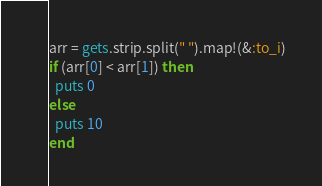Convert code to text. <code><loc_0><loc_0><loc_500><loc_500><_Ruby_>arr = gets.strip.split(" ").map!(&:to_i)
if (arr[0] < arr[1]) then
  puts 0
else
  puts 10
end</code> 